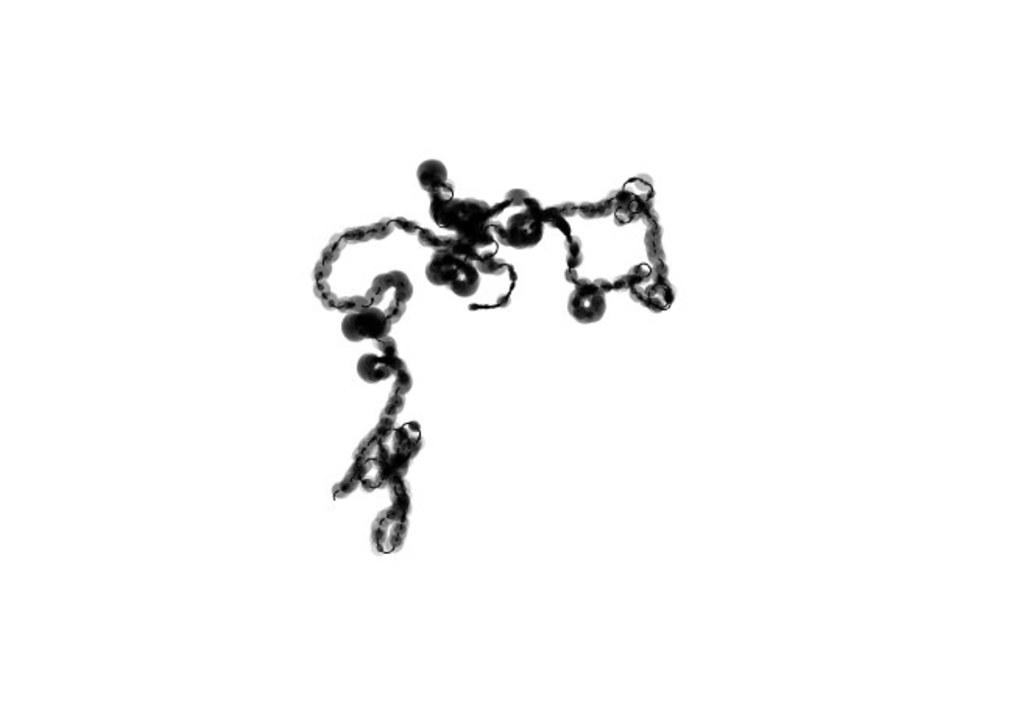What type of image is depicted in the picture? The image appears to be of a DNA cell. What type of technology is used to capture this image? The image is a microscopic image. Can you see any deer or trains in the image? No, there are no deer or trains present in the microscopic image of the DNA cell. 